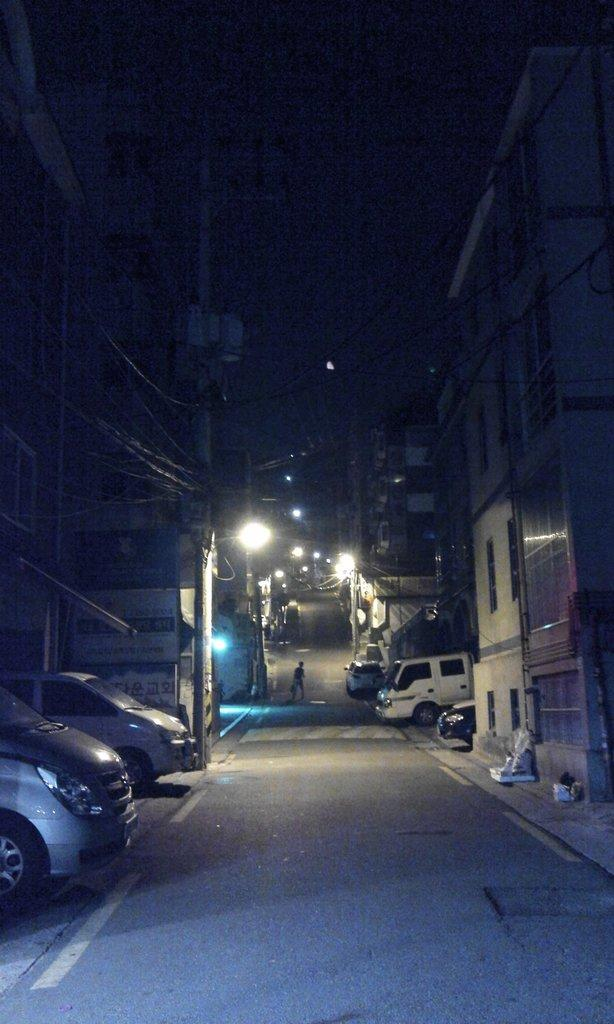What type of structures can be seen in the image? There are buildings in the image. What else can be seen in the image besides buildings? There are poles, vehicles, a person walking on the road, objects on the footpath, and the sky is visible at the top of the image. What is the value of the yak standing next to the person walking on the road in the image? There is no yak present in the image; it only features buildings, poles, vehicles, objects on the footpath, and the sky. 